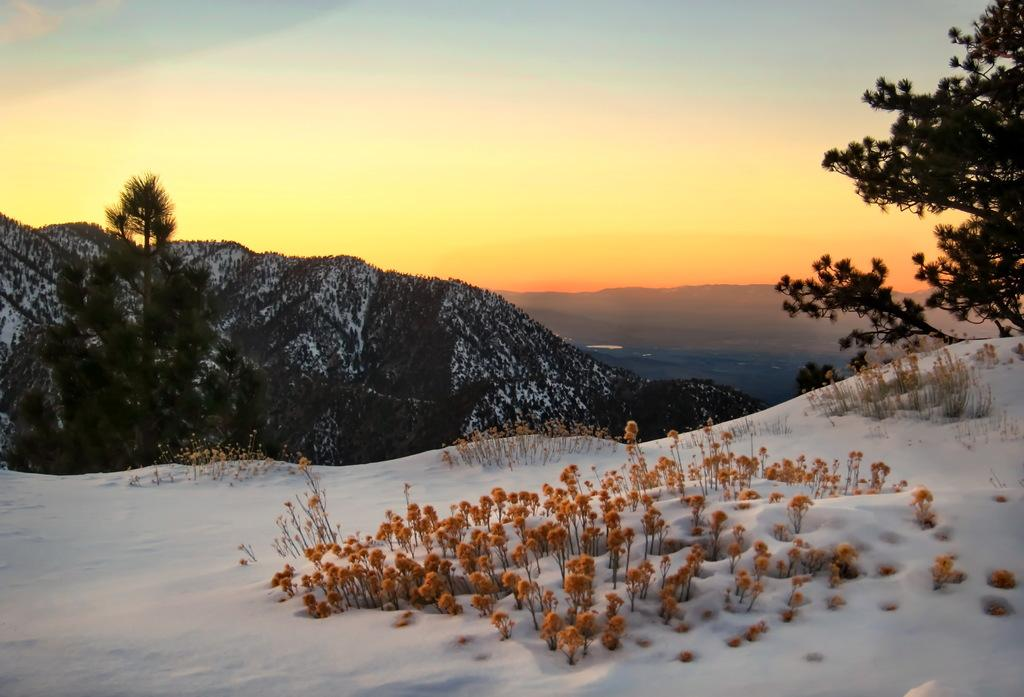What type of weather condition is depicted in the image? There is snow on the land in the image, indicating a snowy or wintry condition. What type of vegetation is present in the image? There are trees in the image. What type of terrain can be seen in the image? There are hills in the image. What is visible in the background of the image? The sky is visible in the background of the image. What type of road can be seen in the image? There is no road present in the image; it features snow-covered land, trees, hills, and a visible sky. 